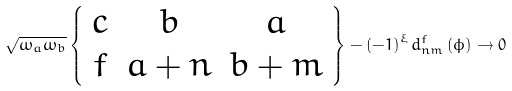<formula> <loc_0><loc_0><loc_500><loc_500>\sqrt { \omega _ { a } \omega _ { b } } \left \{ \begin{array} { c c c } c & b & a \\ f & a + n & b + m \end{array} \right \} - \left ( - 1 \right ) ^ { \xi } d _ { n m } ^ { f } \left ( \phi \right ) \rightarrow 0</formula> 